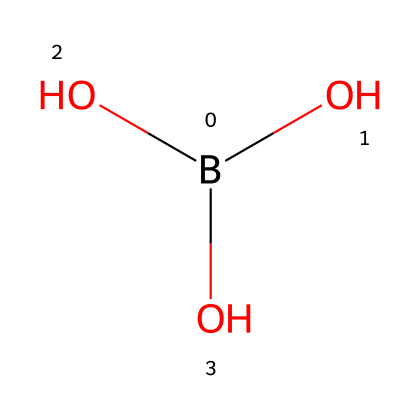What is the molecular formula of this chemical? The chemical structure provided indicates that it contains one boron atom and three oxygen atoms, resulting in the molecular formula B(OH)3.
Answer: B(OH)3 How many hydroxyl groups are present in this molecule? The visual representation shows that there are three -OH groups attached to the boron atom, which are known as hydroxyl groups.
Answer: 3 What type of bonding occurs between boron and oxygen in this molecule? In this chemical, the boron atom is bonded to three oxygen atoms through covalent bonds, which are typically formed by the sharing of electrons between atoms.
Answer: covalent What is the hybridization state of the boron atom in this structure? The boron atom, having three bonding pairs and no lone pairs, undergoes sp3 hybridization, which corresponds to the tetrahedral arrangement of the bonds.
Answer: sp3 Why is this compound considered a boron compound? The compound is considered a boron compound because it contains boron as a key component in its molecular structure, specifically as the central atom bonded to oxygen.
Answer: boron What physical property can this chemical contribute to archival-quality paper? This chemical can provide protection against microbial growth due to its preservative properties, which helps in maintaining the integrity of archival-quality paper over time.
Answer: preservation 